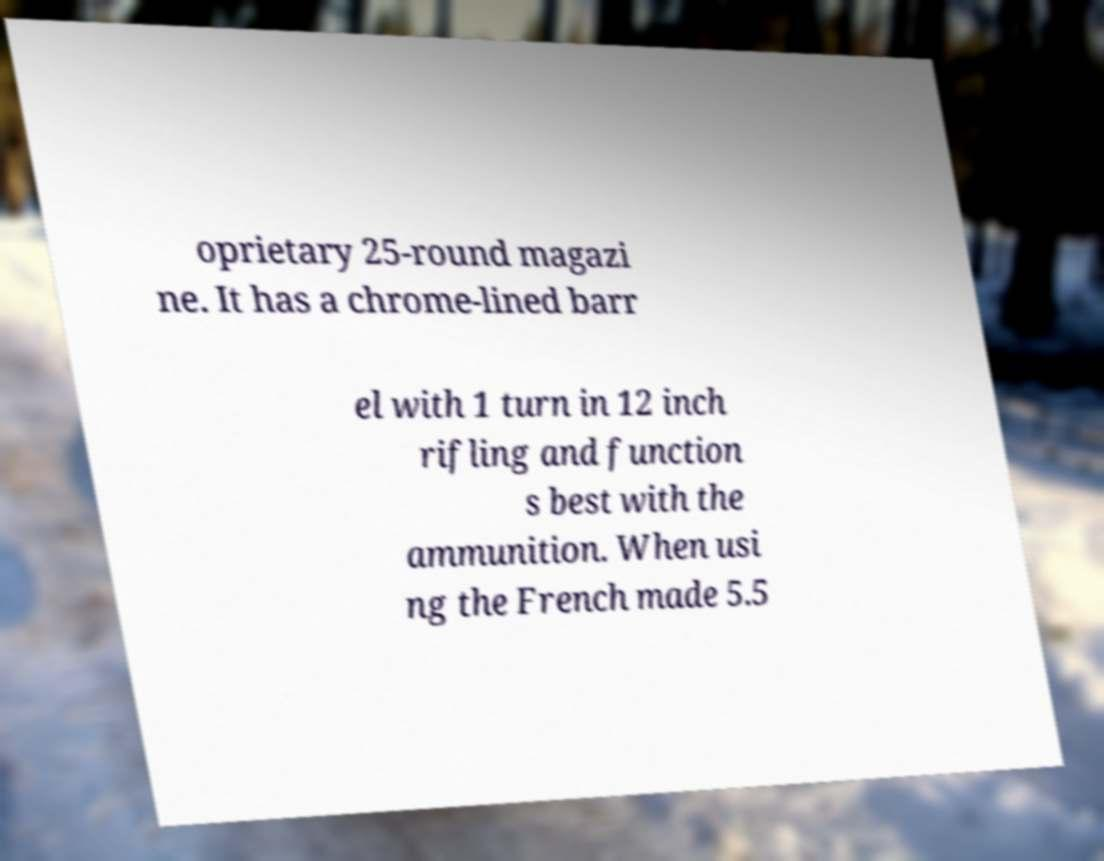Can you accurately transcribe the text from the provided image for me? oprietary 25-round magazi ne. It has a chrome-lined barr el with 1 turn in 12 inch rifling and function s best with the ammunition. When usi ng the French made 5.5 